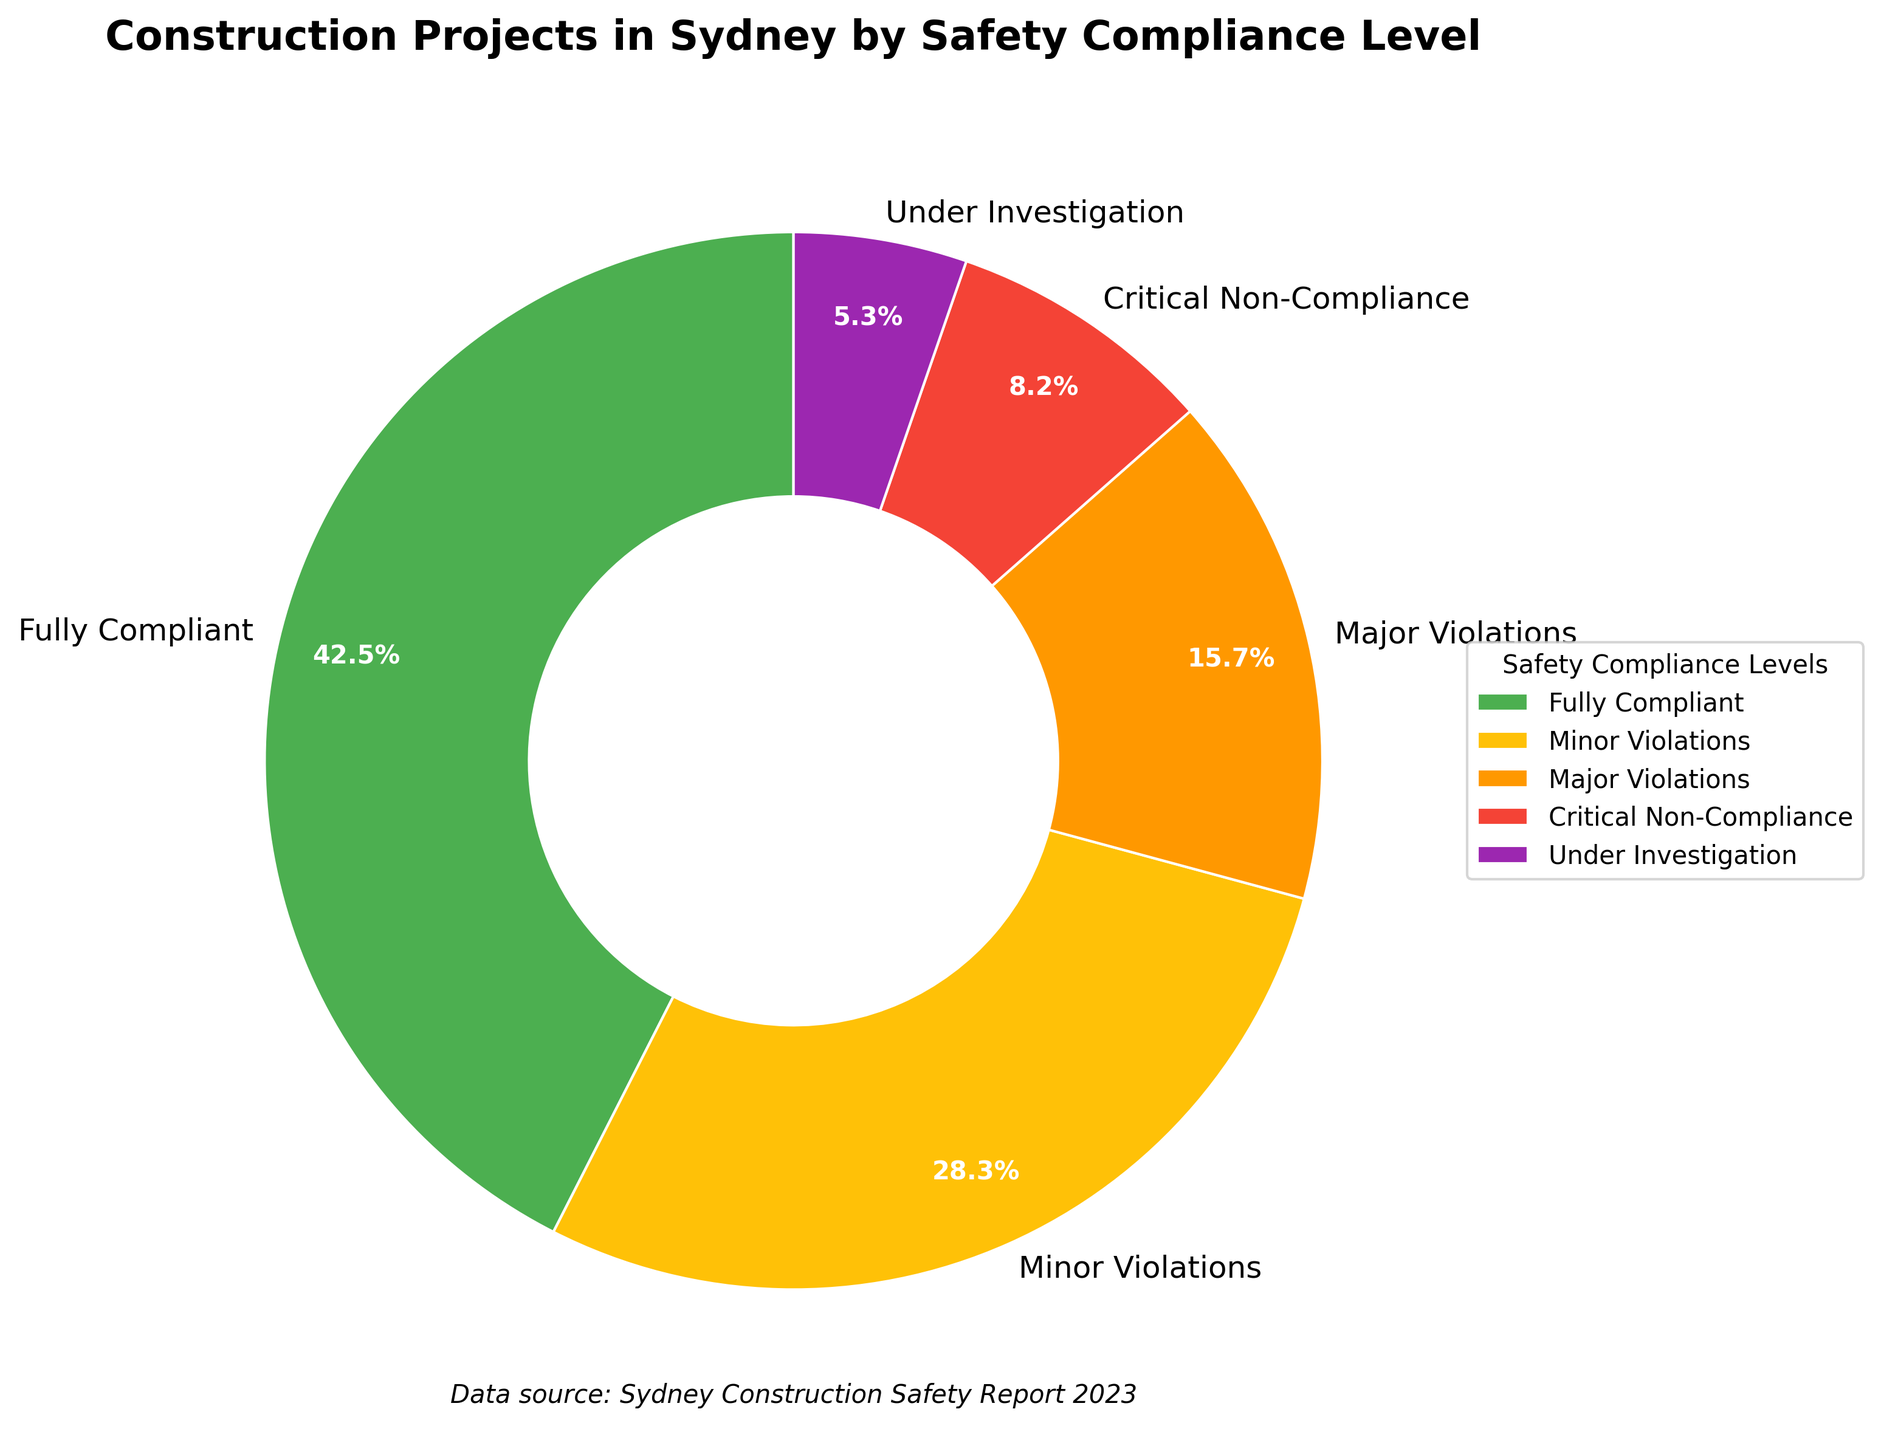What's the percentage of projects that are either Fully Compliant or have Minor Violations? To find the sum of percentages for the "Fully Compliant" and "Minor Violations" categories, add 42.5% (Fully Compliant) and 28.3% (Minor Violations). So, 42.5% + 28.3% = 70.8%.
Answer: 70.8% Which safety compliance level has the highest percentage of projects? The segment with the largest size and the corresponding label (Fully Compliant) represents the highest percentage at 42.5%.
Answer: Fully Compliant Compare the percentage of projects with Critical Non-Compliance to those Under Investigation. Which is greater and by how much? The percentage of projects with Critical Non-Compliance is 8.2%, and those Under Investigation is 5.3%. The difference is 8.2% - 5.3% = 2.9%. Thus, Critical Non-Compliance is greater by 2.9%.
Answer: Critical Non-Compliance by 2.9% Which safety compliance level is represented by the purple color? The segment colored purple is labeled "Under Investigation".
Answer: Under Investigation What percentage of projects have Major Violations or greater levels of non-compliance (including Critical Non-Compliance and Under Investigation)? Add the percentages for Major Violations (15.7%), Critical Non-Compliance (8.2%), and Under Investigation (5.3%). So, 15.7% + 8.2% + 5.3% = 29.2%.
Answer: 29.2% What is the combined percentage of projects that have either Minor or Major Violations? Add the percentages for Minor Violations (28.3%) and Major Violations (15.7%). So, 28.3% + 15.7% = 44.0%.
Answer: 44.0% Are there more projects with Minor Violations or Major Violations, and by what margin? The percentage for Minor Violations is 28.3% and for Major Violations is 15.7%. The difference is 28.3% - 15.7% = 12.6%. Therefore, Minor Violations are more by 12.6%.
Answer: Minor Violations by 12.6% Which safety compliance level has the second highest percentage of projects? After Fully Compliant (42.5%), Minor Violations have the second highest percentage at 28.3%.
Answer: Minor Violations How critical is the percentage represented by Critical Non-Compliance compared to Fully Compliant? Fully Compliant is 42.5%, while Critical Non-Compliance is 8.2%. Compare by taking the ratio 8.2% / 42.5% = 0.193 which approximately means Critical Non-Compliance is 19.3% of Fully Compliant.
Answer: 19.3% How many safety compliance levels are displayed in the pie chart? Count the different segments (labels) in the pie chart. There are five levels: Fully Compliant, Minor Violations, Major Violations, Critical Non-Compliance, and Under Investigation.
Answer: Five 